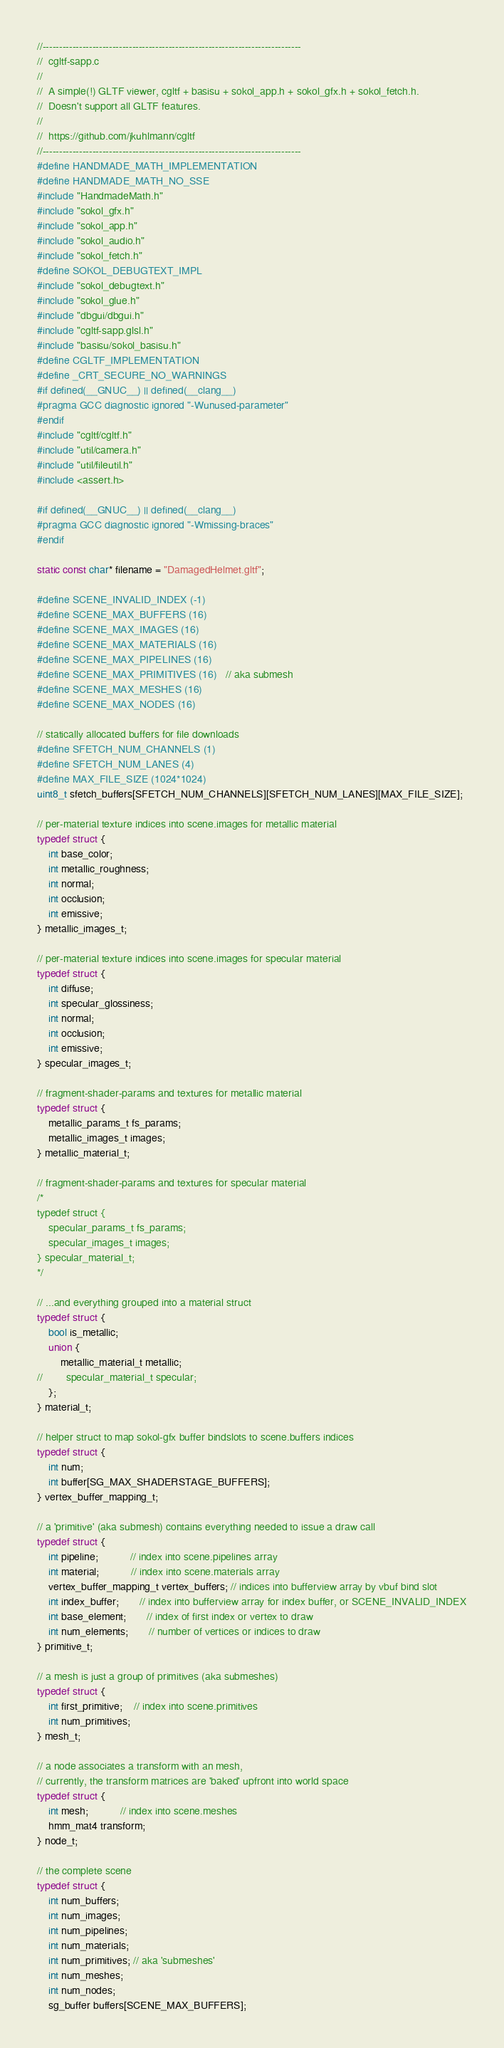<code> <loc_0><loc_0><loc_500><loc_500><_C_>//------------------------------------------------------------------------------
//  cgltf-sapp.c
//
//  A simple(!) GLTF viewer, cgltf + basisu + sokol_app.h + sokol_gfx.h + sokol_fetch.h.
//  Doesn't support all GLTF features.
//
//  https://github.com/jkuhlmann/cgltf
//------------------------------------------------------------------------------
#define HANDMADE_MATH_IMPLEMENTATION
#define HANDMADE_MATH_NO_SSE
#include "HandmadeMath.h"
#include "sokol_gfx.h"
#include "sokol_app.h"
#include "sokol_audio.h"
#include "sokol_fetch.h"
#define SOKOL_DEBUGTEXT_IMPL
#include "sokol_debugtext.h"
#include "sokol_glue.h"
#include "dbgui/dbgui.h"
#include "cgltf-sapp.glsl.h"
#include "basisu/sokol_basisu.h"
#define CGLTF_IMPLEMENTATION
#define _CRT_SECURE_NO_WARNINGS
#if defined(__GNUC__) || defined(__clang__)
#pragma GCC diagnostic ignored "-Wunused-parameter"
#endif
#include "cgltf/cgltf.h"
#include "util/camera.h"
#include "util/fileutil.h"
#include <assert.h>

#if defined(__GNUC__) || defined(__clang__)
#pragma GCC diagnostic ignored "-Wmissing-braces"
#endif

static const char* filename = "DamagedHelmet.gltf";

#define SCENE_INVALID_INDEX (-1)
#define SCENE_MAX_BUFFERS (16)
#define SCENE_MAX_IMAGES (16)
#define SCENE_MAX_MATERIALS (16)
#define SCENE_MAX_PIPELINES (16)
#define SCENE_MAX_PRIMITIVES (16)   // aka submesh
#define SCENE_MAX_MESHES (16)
#define SCENE_MAX_NODES (16)

// statically allocated buffers for file downloads
#define SFETCH_NUM_CHANNELS (1)
#define SFETCH_NUM_LANES (4)
#define MAX_FILE_SIZE (1024*1024)
uint8_t sfetch_buffers[SFETCH_NUM_CHANNELS][SFETCH_NUM_LANES][MAX_FILE_SIZE];

// per-material texture indices into scene.images for metallic material
typedef struct {
    int base_color;
    int metallic_roughness;
    int normal;
    int occlusion;
    int emissive;
} metallic_images_t;

// per-material texture indices into scene.images for specular material
typedef struct {
    int diffuse;
    int specular_glossiness;
    int normal;
    int occlusion;
    int emissive;
} specular_images_t;

// fragment-shader-params and textures for metallic material
typedef struct {
    metallic_params_t fs_params;
    metallic_images_t images;
} metallic_material_t;

// fragment-shader-params and textures for specular material
/*
typedef struct {
    specular_params_t fs_params;
    specular_images_t images;
} specular_material_t;
*/

// ...and everything grouped into a material struct
typedef struct {
    bool is_metallic;
    union {
        metallic_material_t metallic;
//        specular_material_t specular;
    };
} material_t;

// helper struct to map sokol-gfx buffer bindslots to scene.buffers indices
typedef struct {
    int num;
    int buffer[SG_MAX_SHADERSTAGE_BUFFERS];
} vertex_buffer_mapping_t;

// a 'primitive' (aka submesh) contains everything needed to issue a draw call
typedef struct {
    int pipeline;           // index into scene.pipelines array
    int material;           // index into scene.materials array
    vertex_buffer_mapping_t vertex_buffers; // indices into bufferview array by vbuf bind slot
    int index_buffer;       // index into bufferview array for index buffer, or SCENE_INVALID_INDEX
    int base_element;       // index of first index or vertex to draw
    int num_elements;       // number of vertices or indices to draw
} primitive_t;

// a mesh is just a group of primitives (aka submeshes)
typedef struct {
    int first_primitive;    // index into scene.primitives
    int num_primitives;
} mesh_t;

// a node associates a transform with an mesh,
// currently, the transform matrices are 'baked' upfront into world space
typedef struct {
    int mesh;           // index into scene.meshes
    hmm_mat4 transform;
} node_t;

// the complete scene
typedef struct {
    int num_buffers;
    int num_images;
    int num_pipelines;
    int num_materials;
    int num_primitives; // aka 'submeshes'
    int num_meshes;
    int num_nodes;
    sg_buffer buffers[SCENE_MAX_BUFFERS];</code> 